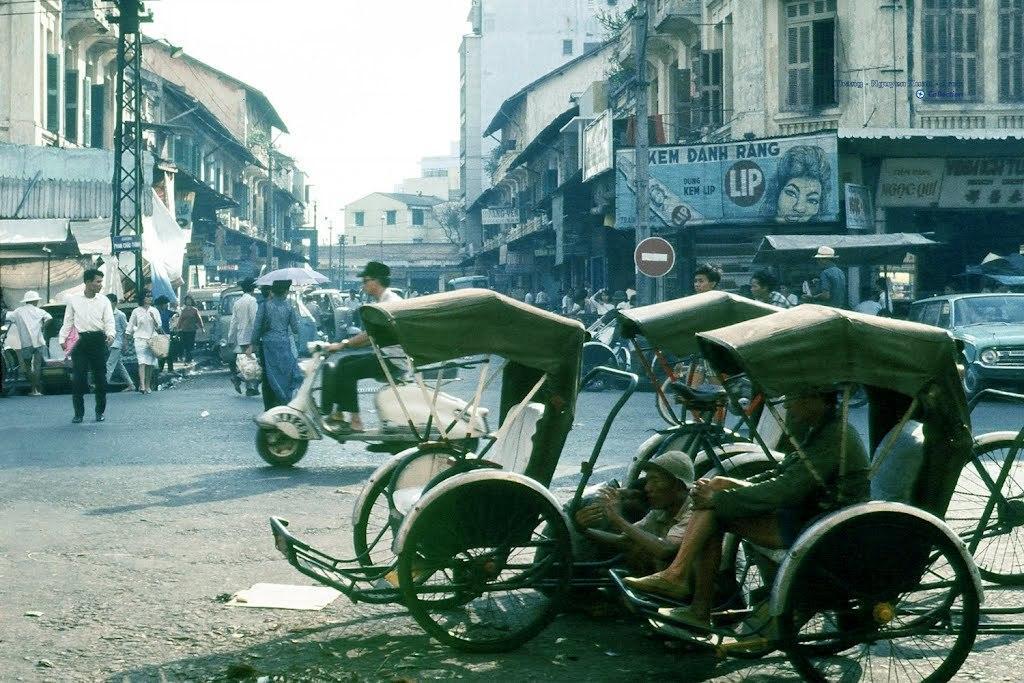Could you give a brief overview of what you see in this image? In this image there is a street in the middle. In the street there are so many vehicles and few people are walking on it. There are buildings on either side of the road. At the bottom there are three rickshaws which are parked one beside the other. In the rickshaws there are people. On the left side there is a pole on the road. Below the buildings there are stores and shops. 